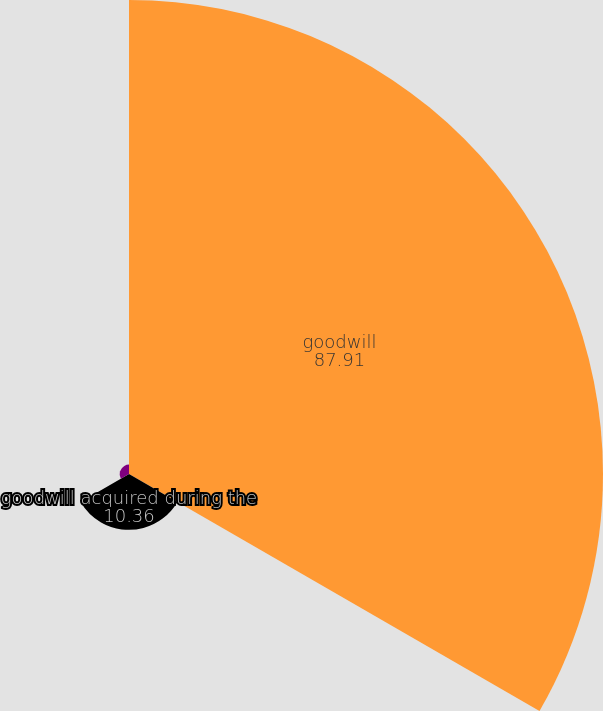Convert chart to OTSL. <chart><loc_0><loc_0><loc_500><loc_500><pie_chart><fcel>goodwill<fcel>goodwill acquired during the<fcel>Translation and other<nl><fcel>87.91%<fcel>10.36%<fcel>1.74%<nl></chart> 